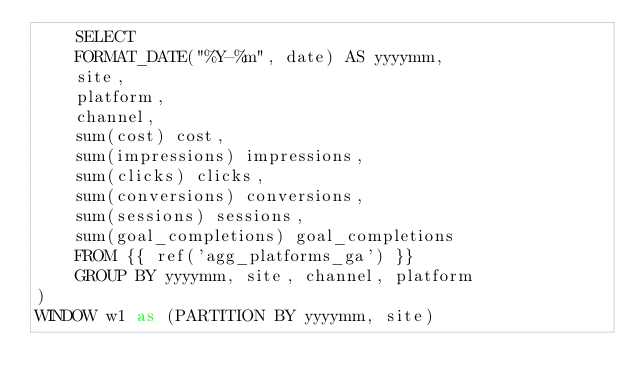Convert code to text. <code><loc_0><loc_0><loc_500><loc_500><_SQL_>    SELECT 
    FORMAT_DATE("%Y-%m", date) AS yyyymm,
    site,
    platform,
    channel, 
    sum(cost) cost,
    sum(impressions) impressions,
    sum(clicks) clicks,
    sum(conversions) conversions,
    sum(sessions) sessions,
    sum(goal_completions) goal_completions
    FROM {{ ref('agg_platforms_ga') }}
    GROUP BY yyyymm, site, channel, platform
)
WINDOW w1 as (PARTITION BY yyyymm, site)</code> 